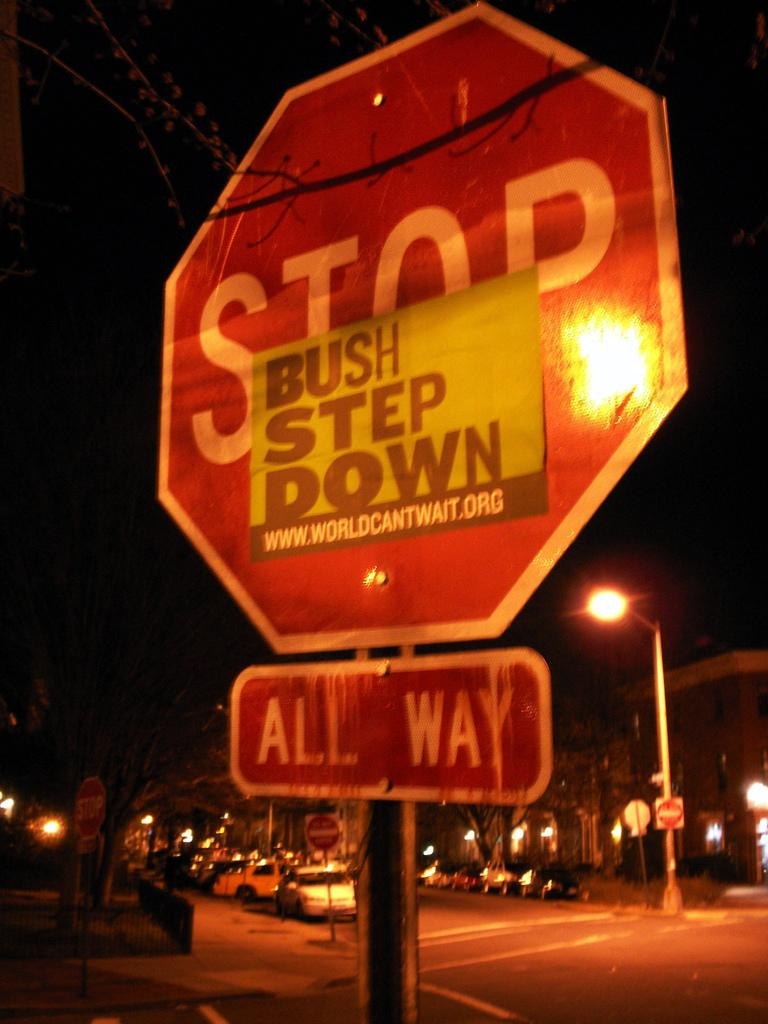Provide a one-sentence caption for the provided image. The small sign on the stop sign says Bush Step Down. 